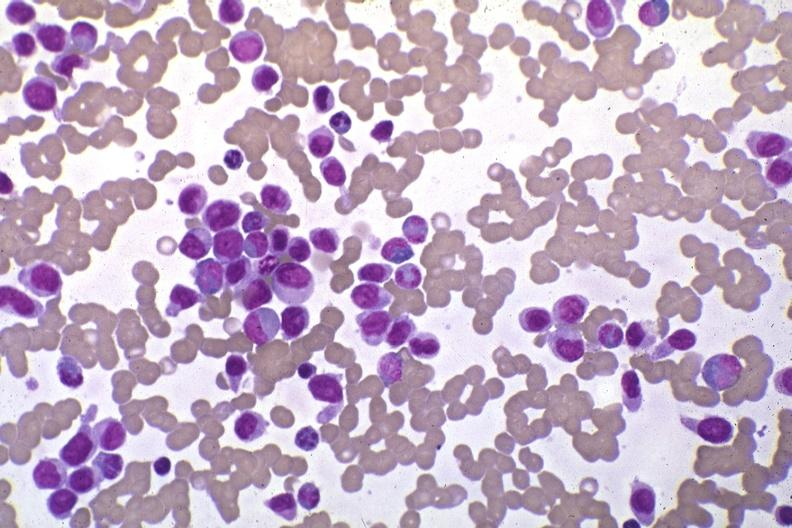what stain pleomorphic leukemic cells in peripheral blood prior to therapy?
Answer the question using a single word or phrase. Wrights 